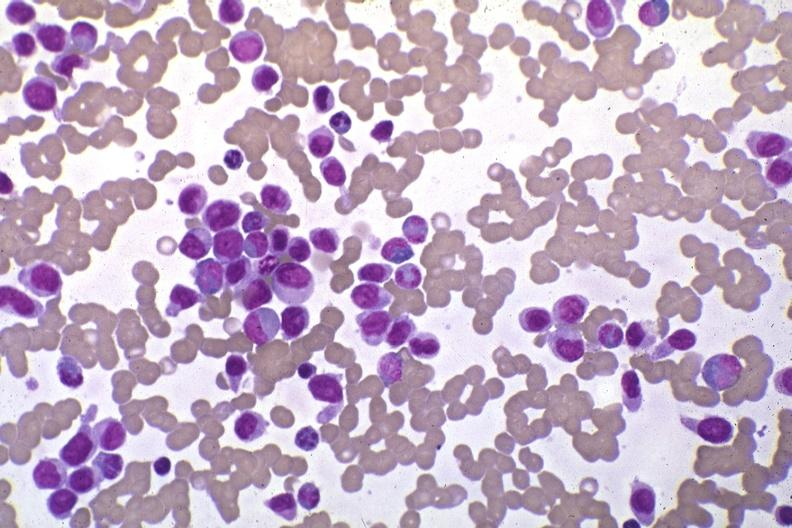what stain pleomorphic leukemic cells in peripheral blood prior to therapy?
Answer the question using a single word or phrase. Wrights 